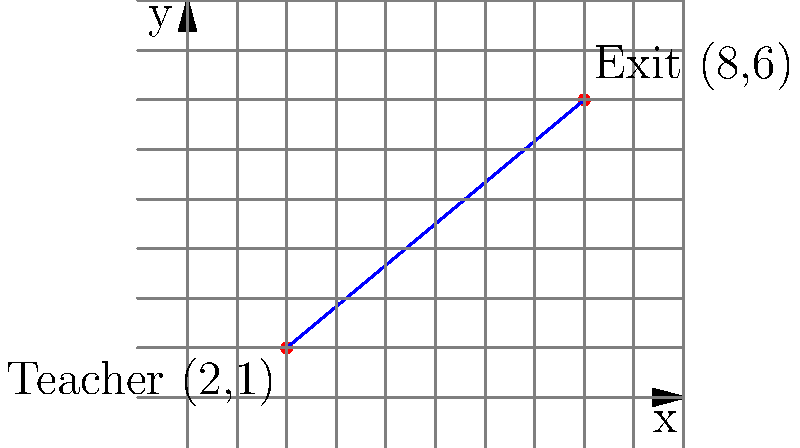In a desperate attempt to escape the monotony of your classroom, you plot your daring exit strategy on a coordinate plane. Your current position is at (2,1), while the tantalizing exit door beckons at (8,6). What's the equation of the line that represents your path to freedom? Express your answer in slope-intercept form, $y = mx + b$. Let's approach this with the enthusiasm of a teacher who'd rather be anywhere else:

1) First, we need to find the slope (m) of the line. We'll use the slope formula:
   $m = \frac{y_2 - y_1}{x_2 - x_1}$

2) Plug in the coordinates:
   $m = \frac{6 - 1}{8 - 2} = \frac{5}{6}$

3) Now that we have the slope, we can use the point-slope form of a line:
   $y - y_1 = m(x - x_1)$

4) Let's use the point (2,1) and plug everything in:
   $y - 1 = \frac{5}{6}(x - 2)$

5) Distribute the $\frac{5}{6}$:
   $y - 1 = \frac{5}{6}x - \frac{10}{6}$

6) Add 1 to both sides:
   $y = \frac{5}{6}x - \frac{10}{6} + 1$

7) Simplify:
   $y = \frac{5}{6}x - \frac{4}{6}$

8) If we want to be really picky (and what English teacher doesn't?), we can simplify $\frac{4}{6}$ to $\frac{2}{3}$:
   $y = \frac{5}{6}x - \frac{2}{3}$

And there you have it, your escape route equation, should you choose to accept it.
Answer: $y = \frac{5}{6}x - \frac{2}{3}$ 